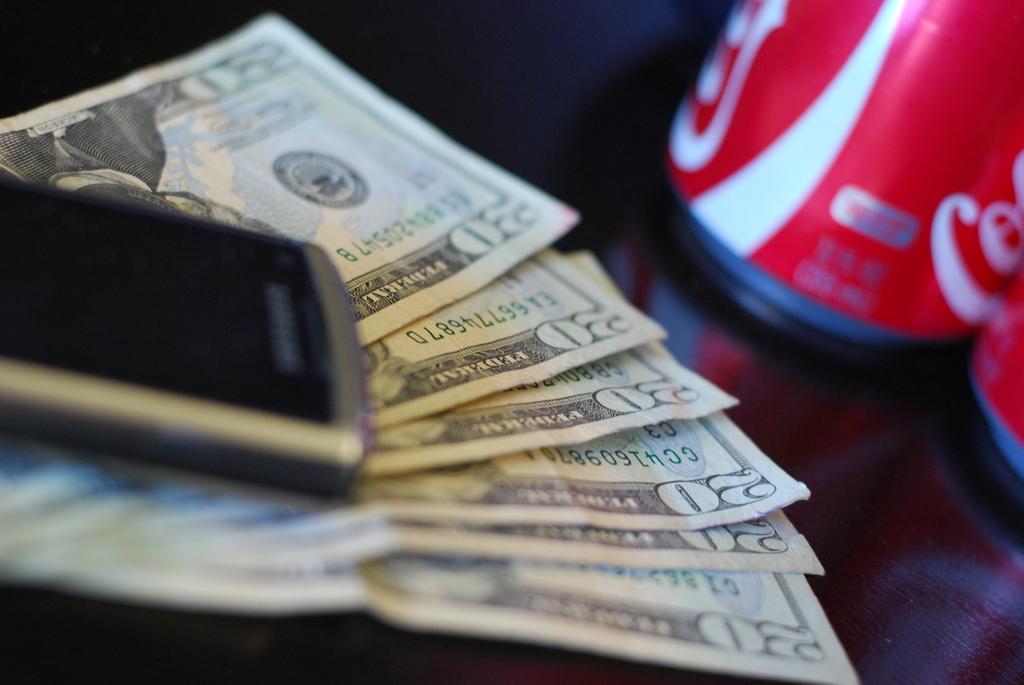What is the word to the right of the number 20 at the top of these bills?
Make the answer very short. Federal. 